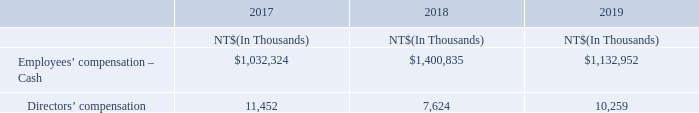The Company recognizes the employees and directors’ compensation in the profit or loss during the periods when earned for the years ended December 31, 2017, 2018 and 2019. The Board of Directors estimates the amount by taking into consideration the Articles of Incorporation, government regulations and industry averages.
If the Board of Directors resolves to distribute employee compensation
through stock, the number of stock distributed is calculated based on total employee compensation divided by the closing price of the day before the Board of Directors meeting. If the Board of Directors subsequently modifies the estimates significantly, the Company will recognize the change as an adjustment in the profit or loss in the subsequent period.
The distributions of employees and directors’ compensation for 2017 and 2018 were reported to the stockholders’ meeting on June 12, 2018 and June 12, 2019, respectively, while the distributions of employees and directors’ compensation for 2019 were approved through the Board of Directors meeting on February 26, 2020. The details of distribution are as follows:
The aforementioned employees and directors’ compensation for 2017 and 2018 reported during the stockholders’ meeting were consistent with the resolutions of the Board of Directors meeting held on March 7, 2018 and March 6, 2019, respectively.
Information relevant to the aforementioned employees and directors’ compensation can be obtained from the “Market Observation Post System” on the website of the TWSE.
How does the the Board of Directors estimates the compensation amount? The board of directors estimates the amount by taking into consideration the articles of incorporation, government regulations and industry averages. When was the distributions of employees and directors’ compensation for 2017 and 2018 reported? June 12, 2018, june 12, 2019. Where can the Information relevant to the aforementioned employees and directors’ compensation be obtained? “market observation post system” on the website of the twse. What is the average Directors’ compensation?
Answer scale should be: thousand. (11,452+7,624+10,259) / 3
Answer: 9778.33. What is the increase/ (decrease) in Directors’ compensation from 2018 to 2019?
Answer scale should be: thousand. 10,259-7,624
Answer: 2635. What is the increase/ (decrease) in Employees’ compensation – Cash from 2018 to 2019?
Answer scale should be: thousand. 1,132,952-1,400,835
Answer: -267883. 